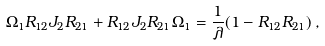Convert formula to latex. <formula><loc_0><loc_0><loc_500><loc_500>\Omega _ { 1 } R _ { 1 2 } J _ { 2 } R _ { 2 1 } + R _ { 1 2 } J _ { 2 } R _ { 2 1 } \Omega _ { 1 } = \frac { 1 } { \lambda } ( 1 - R _ { 1 2 } R _ { 2 1 } ) \, ,</formula> 